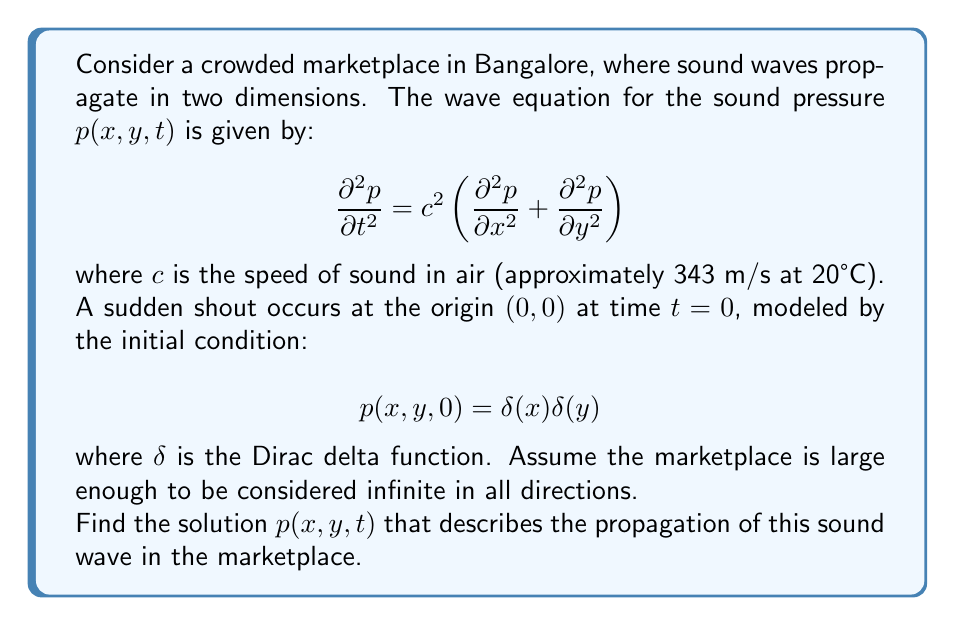What is the answer to this math problem? To solve this problem, we'll follow these steps:

1) First, we recognize that this is a 2D wave equation with an initial point source. The solution will be radially symmetric.

2) We can transform the equation to polar coordinates $(r,\theta)$ where $r^2 = x^2 + y^2$. Due to radial symmetry, the solution won't depend on $\theta$.

3) In polar coordinates, the wave equation becomes:

   $$\frac{\partial^2 p}{\partial t^2} = c^2 \left(\frac{\partial^2 p}{\partial r^2} + \frac{1}{r}\frac{\partial p}{\partial r}\right)$$

4) We can solve this using the method of Fourier transforms. Let's define the 2D Fourier transform of $p$ as:

   $$P(k_x,k_y,t) = \int_{-\infty}^{\infty}\int_{-\infty}^{\infty} p(x,y,t)e^{-i(k_xx+k_yy)}dxdy$$

5) Applying this transform to our wave equation gives:

   $$\frac{\partial^2 P}{\partial t^2} = -c^2(k_x^2+k_y^2)P$$

6) The solution to this ordinary differential equation in $t$ is:

   $$P(k_x,k_y,t) = A(k_x,k_y)\cos(c\sqrt{k_x^2+k_y^2}t) + B(k_x,k_y)\sin(c\sqrt{k_x^2+k_y^2}t)$$

7) Using the initial conditions, we can determine that $A(k_x,k_y) = 1$ and $B(k_x,k_y) = 0$.

8) Now we need to take the inverse Fourier transform:

   $$p(x,y,t) = \frac{1}{4\pi^2}\int_{-\infty}^{\infty}\int_{-\infty}^{\infty} \cos(c\sqrt{k_x^2+k_y^2}t)e^{i(k_xx+k_yy)}dk_xdk_y$$

9) This integral can be evaluated in polar coordinates $(k_r,\theta)$ in k-space:

   $$p(r,t) = \frac{1}{2\pi}\int_0^{\infty} k_r \cos(ck_rt)J_0(k_rr)dk_r$$

   where $J_0$ is the Bessel function of the first kind of order zero.

10) This integral is known and has the solution:

    $$p(r,t) = \frac{1}{2\pi}\frac{H(ct-r)}{\sqrt{c^2t^2-r^2}}$$

    where $H$ is the Heaviside step function.

11) Transforming back to Cartesian coordinates:

    $$p(x,y,t) = \frac{1}{2\pi}\frac{H(ct-\sqrt{x^2+y^2})}{\sqrt{c^2t^2-x^2-y^2}}$$
Answer: The solution to the wave equation modeling the propagation of sound from a sudden shout in a Bangalore marketplace is:

$$p(x,y,t) = \frac{1}{2\pi}\frac{H(ct-\sqrt{x^2+y^2})}{\sqrt{c^2t^2-x^2-y^2}}$$

where $H$ is the Heaviside step function, $c$ is the speed of sound, $t$ is time, and $(x,y)$ are the Cartesian coordinates in the marketplace. 